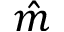Convert formula to latex. <formula><loc_0><loc_0><loc_500><loc_500>\hat { m }</formula> 